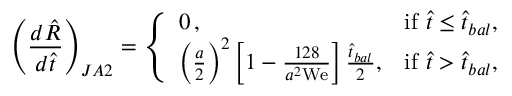<formula> <loc_0><loc_0><loc_500><loc_500>\left ( \frac { d \hat { R } } { d \hat { t } } \right ) _ { J A 2 } = \left \{ \begin{array} { l l } { 0 \, , } & { i f \hat { t } \leq \hat { t } _ { b a l } , } \\ { \left ( \frac { a } { 2 } \right ) ^ { 2 } \left [ 1 - \frac { 1 2 8 } { a ^ { 2 } W e } \right ] \frac { \hat { t } _ { b a l } } { 2 } , } & { i f \hat { t } > \hat { t } _ { b a l } , } \end{array}</formula> 